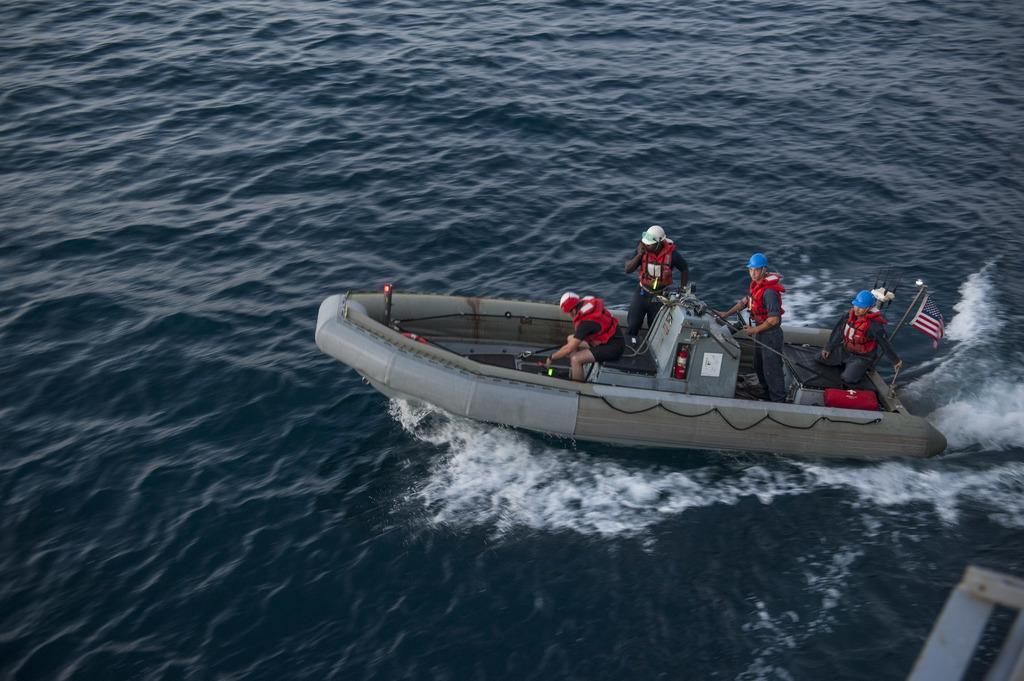Please provide a concise description of this image. In this picture we can see few people in the boat, and they wore red color jackets, and also we can see a flag and water. 